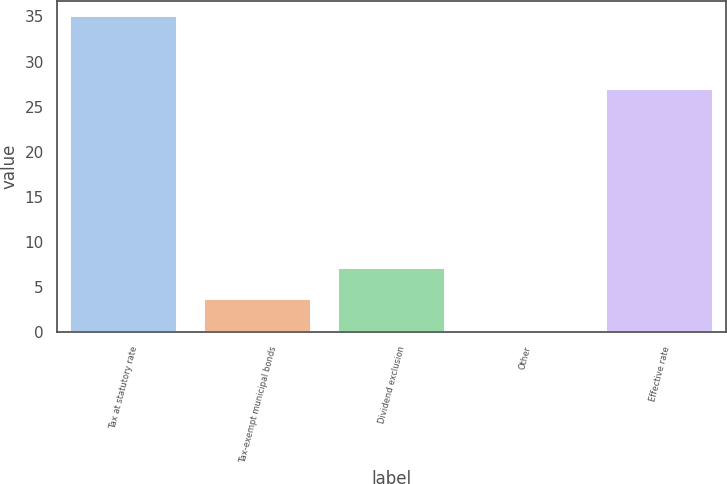Convert chart. <chart><loc_0><loc_0><loc_500><loc_500><bar_chart><fcel>Tax at statutory rate<fcel>Tax-exempt municipal bonds<fcel>Dividend exclusion<fcel>Other<fcel>Effective rate<nl><fcel>35<fcel>3.68<fcel>7.16<fcel>0.2<fcel>27<nl></chart> 